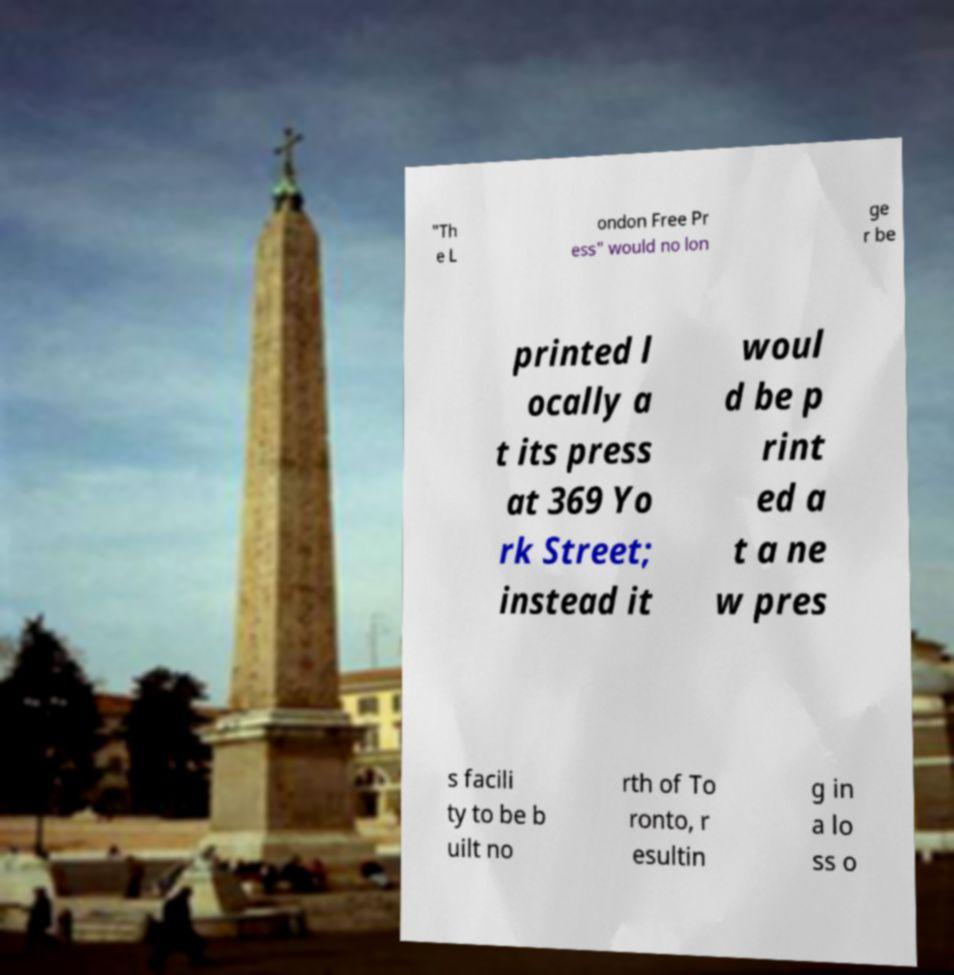For documentation purposes, I need the text within this image transcribed. Could you provide that? "Th e L ondon Free Pr ess" would no lon ge r be printed l ocally a t its press at 369 Yo rk Street; instead it woul d be p rint ed a t a ne w pres s facili ty to be b uilt no rth of To ronto, r esultin g in a lo ss o 